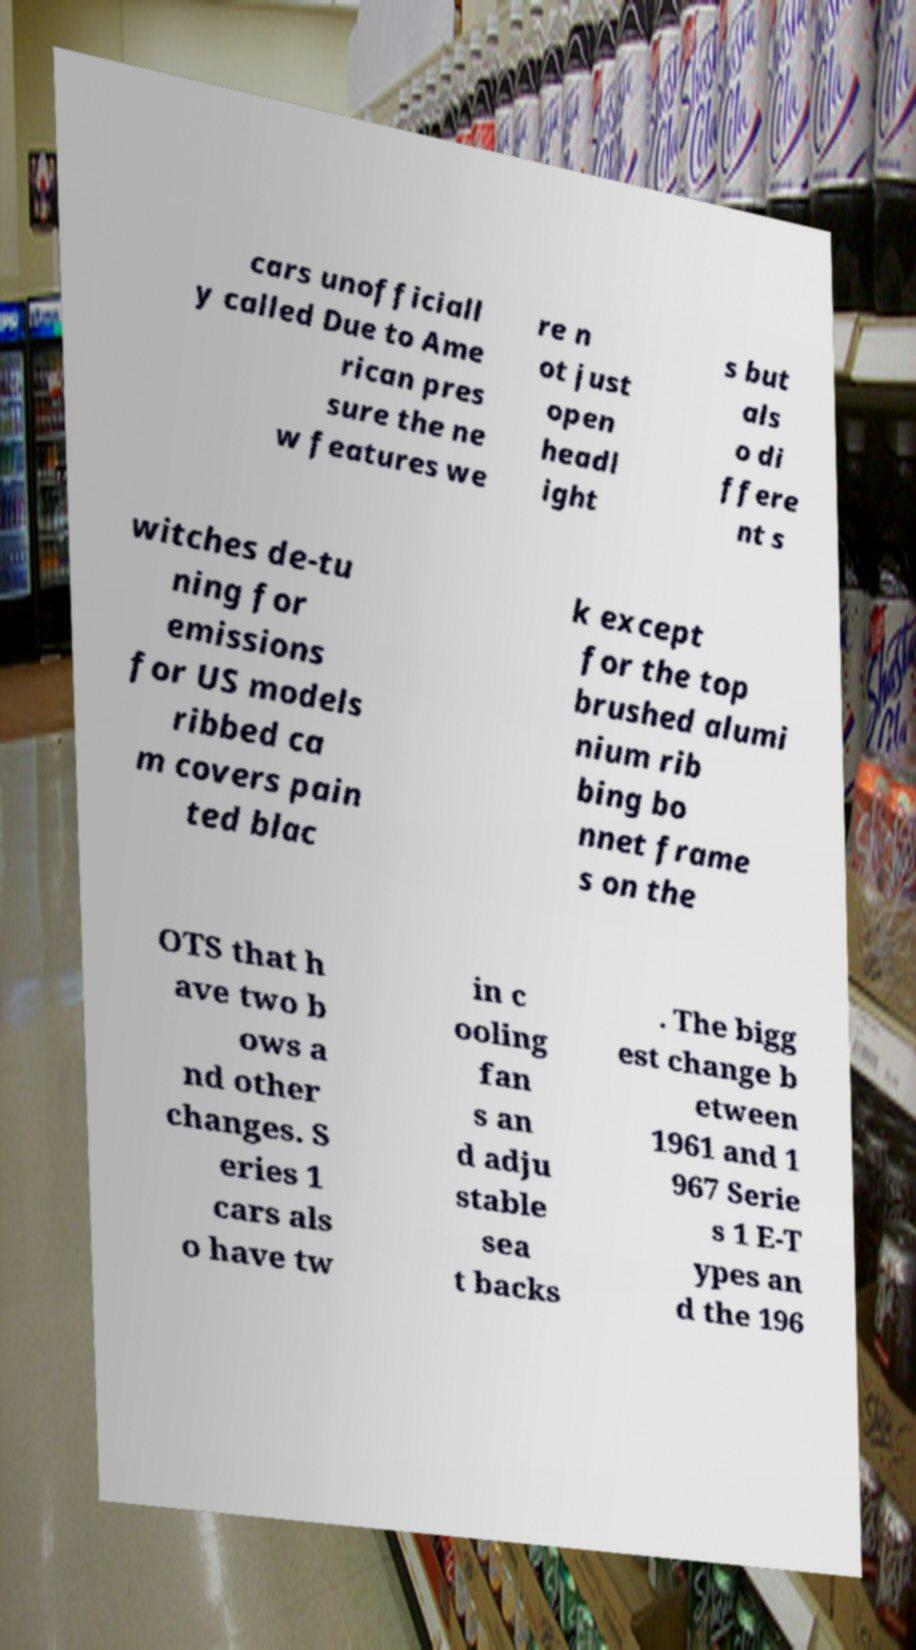I need the written content from this picture converted into text. Can you do that? cars unofficiall y called Due to Ame rican pres sure the ne w features we re n ot just open headl ight s but als o di ffere nt s witches de-tu ning for emissions for US models ribbed ca m covers pain ted blac k except for the top brushed alumi nium rib bing bo nnet frame s on the OTS that h ave two b ows a nd other changes. S eries 1 cars als o have tw in c ooling fan s an d adju stable sea t backs . The bigg est change b etween 1961 and 1 967 Serie s 1 E-T ypes an d the 196 